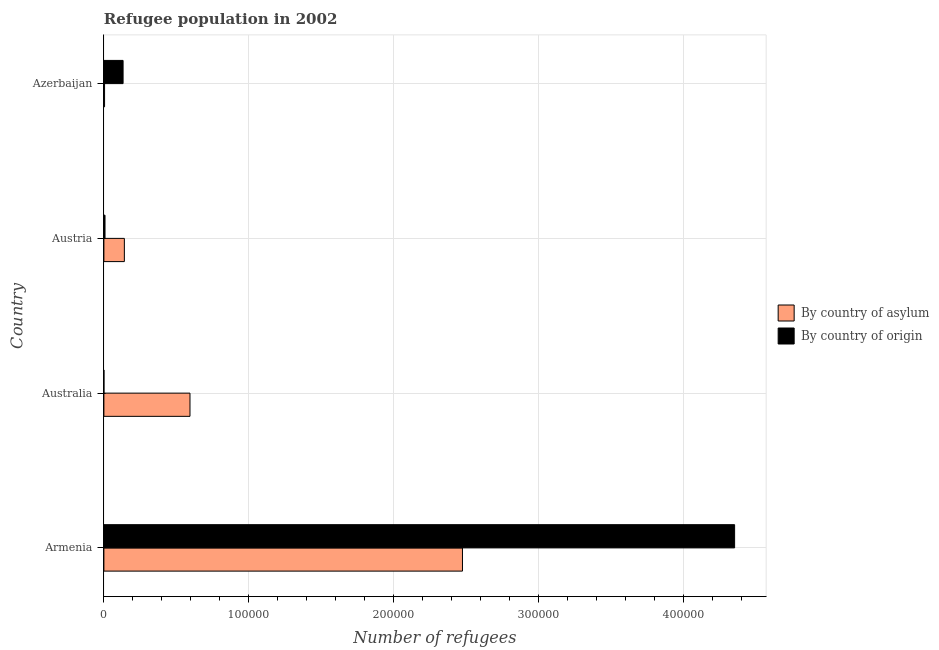How many different coloured bars are there?
Your response must be concise. 2. How many groups of bars are there?
Offer a terse response. 4. Are the number of bars per tick equal to the number of legend labels?
Ensure brevity in your answer.  Yes. How many bars are there on the 1st tick from the bottom?
Your answer should be very brief. 2. What is the label of the 4th group of bars from the top?
Give a very brief answer. Armenia. In how many cases, is the number of bars for a given country not equal to the number of legend labels?
Offer a very short reply. 0. What is the number of refugees by country of asylum in Armenia?
Ensure brevity in your answer.  2.48e+05. Across all countries, what is the maximum number of refugees by country of asylum?
Make the answer very short. 2.48e+05. Across all countries, what is the minimum number of refugees by country of asylum?
Provide a short and direct response. 458. In which country was the number of refugees by country of origin maximum?
Give a very brief answer. Armenia. In which country was the number of refugees by country of asylum minimum?
Offer a terse response. Azerbaijan. What is the total number of refugees by country of asylum in the graph?
Give a very brief answer. 3.22e+05. What is the difference between the number of refugees by country of origin in Armenia and that in Azerbaijan?
Your answer should be compact. 4.22e+05. What is the difference between the number of refugees by country of origin in Austria and the number of refugees by country of asylum in Azerbaijan?
Your answer should be compact. 313. What is the average number of refugees by country of asylum per country?
Give a very brief answer. 8.04e+04. What is the difference between the number of refugees by country of asylum and number of refugees by country of origin in Armenia?
Offer a very short reply. -1.88e+05. In how many countries, is the number of refugees by country of origin greater than 340000 ?
Keep it short and to the point. 1. What is the ratio of the number of refugees by country of asylum in Armenia to that in Azerbaijan?
Provide a succinct answer. 540.5. Is the number of refugees by country of asylum in Australia less than that in Azerbaijan?
Your answer should be compact. No. Is the difference between the number of refugees by country of origin in Armenia and Australia greater than the difference between the number of refugees by country of asylum in Armenia and Australia?
Give a very brief answer. Yes. What is the difference between the highest and the second highest number of refugees by country of origin?
Offer a terse response. 4.22e+05. What is the difference between the highest and the lowest number of refugees by country of origin?
Ensure brevity in your answer.  4.35e+05. In how many countries, is the number of refugees by country of origin greater than the average number of refugees by country of origin taken over all countries?
Offer a terse response. 1. Is the sum of the number of refugees by country of origin in Austria and Azerbaijan greater than the maximum number of refugees by country of asylum across all countries?
Your response must be concise. No. What does the 1st bar from the top in Australia represents?
Your answer should be very brief. By country of origin. What does the 1st bar from the bottom in Australia represents?
Provide a short and direct response. By country of asylum. How many bars are there?
Offer a very short reply. 8. Are all the bars in the graph horizontal?
Your answer should be very brief. Yes. Does the graph contain any zero values?
Provide a succinct answer. No. How are the legend labels stacked?
Offer a terse response. Vertical. What is the title of the graph?
Provide a succinct answer. Refugee population in 2002. What is the label or title of the X-axis?
Your answer should be very brief. Number of refugees. What is the Number of refugees of By country of asylum in Armenia?
Offer a very short reply. 2.48e+05. What is the Number of refugees in By country of origin in Armenia?
Your response must be concise. 4.35e+05. What is the Number of refugees in By country of asylum in Australia?
Offer a terse response. 5.94e+04. What is the Number of refugees of By country of origin in Australia?
Provide a short and direct response. 5. What is the Number of refugees of By country of asylum in Austria?
Your answer should be compact. 1.41e+04. What is the Number of refugees of By country of origin in Austria?
Your response must be concise. 771. What is the Number of refugees in By country of asylum in Azerbaijan?
Ensure brevity in your answer.  458. What is the Number of refugees of By country of origin in Azerbaijan?
Offer a terse response. 1.32e+04. Across all countries, what is the maximum Number of refugees of By country of asylum?
Provide a short and direct response. 2.48e+05. Across all countries, what is the maximum Number of refugees in By country of origin?
Offer a very short reply. 4.35e+05. Across all countries, what is the minimum Number of refugees in By country of asylum?
Give a very brief answer. 458. Across all countries, what is the minimum Number of refugees of By country of origin?
Your answer should be compact. 5. What is the total Number of refugees of By country of asylum in the graph?
Your answer should be very brief. 3.22e+05. What is the total Number of refugees of By country of origin in the graph?
Offer a very short reply. 4.49e+05. What is the difference between the Number of refugees in By country of asylum in Armenia and that in Australia?
Give a very brief answer. 1.88e+05. What is the difference between the Number of refugees of By country of origin in Armenia and that in Australia?
Your answer should be compact. 4.35e+05. What is the difference between the Number of refugees in By country of asylum in Armenia and that in Austria?
Your answer should be compact. 2.33e+05. What is the difference between the Number of refugees of By country of origin in Armenia and that in Austria?
Keep it short and to the point. 4.35e+05. What is the difference between the Number of refugees of By country of asylum in Armenia and that in Azerbaijan?
Offer a very short reply. 2.47e+05. What is the difference between the Number of refugees of By country of origin in Armenia and that in Azerbaijan?
Offer a terse response. 4.22e+05. What is the difference between the Number of refugees in By country of asylum in Australia and that in Austria?
Provide a succinct answer. 4.53e+04. What is the difference between the Number of refugees in By country of origin in Australia and that in Austria?
Your answer should be very brief. -766. What is the difference between the Number of refugees in By country of asylum in Australia and that in Azerbaijan?
Offer a terse response. 5.90e+04. What is the difference between the Number of refugees of By country of origin in Australia and that in Azerbaijan?
Your answer should be compact. -1.32e+04. What is the difference between the Number of refugees in By country of asylum in Austria and that in Azerbaijan?
Make the answer very short. 1.37e+04. What is the difference between the Number of refugees of By country of origin in Austria and that in Azerbaijan?
Offer a very short reply. -1.25e+04. What is the difference between the Number of refugees of By country of asylum in Armenia and the Number of refugees of By country of origin in Australia?
Provide a succinct answer. 2.48e+05. What is the difference between the Number of refugees in By country of asylum in Armenia and the Number of refugees in By country of origin in Austria?
Make the answer very short. 2.47e+05. What is the difference between the Number of refugees of By country of asylum in Armenia and the Number of refugees of By country of origin in Azerbaijan?
Give a very brief answer. 2.34e+05. What is the difference between the Number of refugees of By country of asylum in Australia and the Number of refugees of By country of origin in Austria?
Ensure brevity in your answer.  5.87e+04. What is the difference between the Number of refugees in By country of asylum in Australia and the Number of refugees in By country of origin in Azerbaijan?
Your response must be concise. 4.62e+04. What is the difference between the Number of refugees of By country of asylum in Austria and the Number of refugees of By country of origin in Azerbaijan?
Offer a very short reply. 881. What is the average Number of refugees in By country of asylum per country?
Your answer should be compact. 8.04e+04. What is the average Number of refugees of By country of origin per country?
Your answer should be very brief. 1.12e+05. What is the difference between the Number of refugees in By country of asylum and Number of refugees in By country of origin in Armenia?
Give a very brief answer. -1.88e+05. What is the difference between the Number of refugees of By country of asylum and Number of refugees of By country of origin in Australia?
Provide a short and direct response. 5.94e+04. What is the difference between the Number of refugees in By country of asylum and Number of refugees in By country of origin in Austria?
Offer a terse response. 1.34e+04. What is the difference between the Number of refugees in By country of asylum and Number of refugees in By country of origin in Azerbaijan?
Offer a terse response. -1.28e+04. What is the ratio of the Number of refugees in By country of asylum in Armenia to that in Australia?
Provide a short and direct response. 4.17. What is the ratio of the Number of refugees in By country of origin in Armenia to that in Australia?
Your response must be concise. 8.71e+04. What is the ratio of the Number of refugees in By country of asylum in Armenia to that in Austria?
Your response must be concise. 17.52. What is the ratio of the Number of refugees of By country of origin in Armenia to that in Austria?
Your response must be concise. 564.75. What is the ratio of the Number of refugees in By country of asylum in Armenia to that in Azerbaijan?
Make the answer very short. 540.5. What is the ratio of the Number of refugees in By country of origin in Armenia to that in Azerbaijan?
Offer a terse response. 32.86. What is the ratio of the Number of refugees of By country of asylum in Australia to that in Austria?
Keep it short and to the point. 4.21. What is the ratio of the Number of refugees of By country of origin in Australia to that in Austria?
Your response must be concise. 0.01. What is the ratio of the Number of refugees in By country of asylum in Australia to that in Azerbaijan?
Your response must be concise. 129.77. What is the ratio of the Number of refugees in By country of origin in Australia to that in Azerbaijan?
Keep it short and to the point. 0. What is the ratio of the Number of refugees of By country of asylum in Austria to that in Azerbaijan?
Your answer should be very brief. 30.85. What is the ratio of the Number of refugees of By country of origin in Austria to that in Azerbaijan?
Ensure brevity in your answer.  0.06. What is the difference between the highest and the second highest Number of refugees in By country of asylum?
Give a very brief answer. 1.88e+05. What is the difference between the highest and the second highest Number of refugees in By country of origin?
Offer a very short reply. 4.22e+05. What is the difference between the highest and the lowest Number of refugees of By country of asylum?
Your response must be concise. 2.47e+05. What is the difference between the highest and the lowest Number of refugees of By country of origin?
Provide a succinct answer. 4.35e+05. 